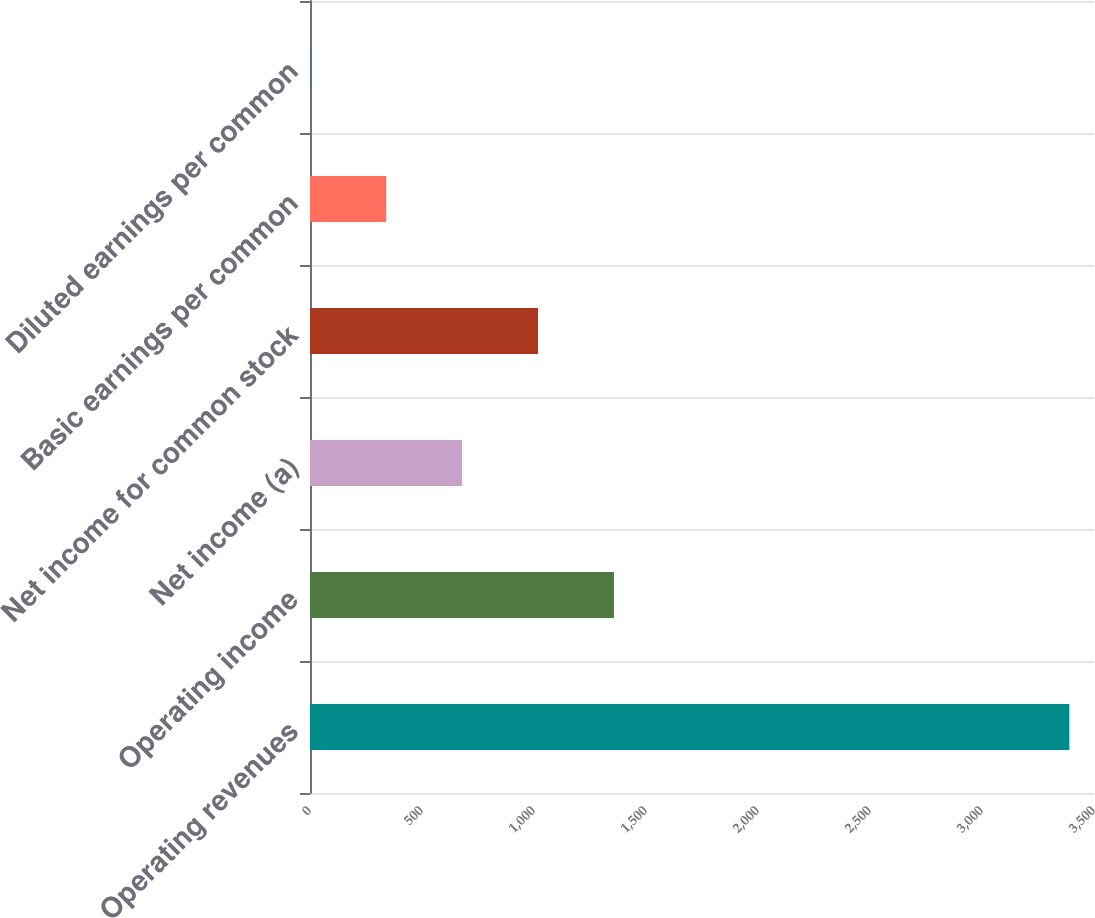Convert chart to OTSL. <chart><loc_0><loc_0><loc_500><loc_500><bar_chart><fcel>Operating revenues<fcel>Operating income<fcel>Net income (a)<fcel>Net income for common stock<fcel>Basic earnings per common<fcel>Diluted earnings per common<nl><fcel>3390<fcel>1356.88<fcel>679.18<fcel>1018.03<fcel>340.33<fcel>1.48<nl></chart> 